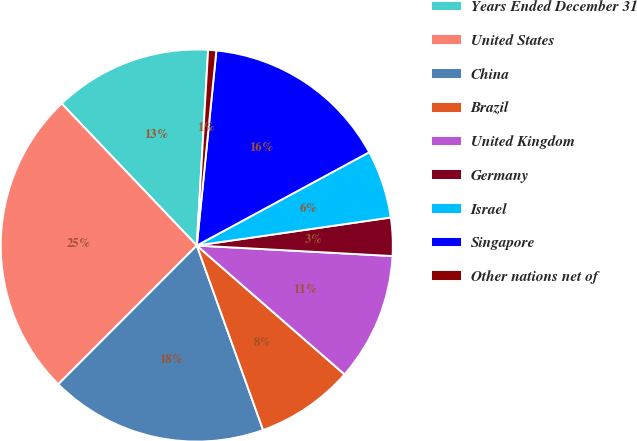Convert chart. <chart><loc_0><loc_0><loc_500><loc_500><pie_chart><fcel>Years Ended December 31<fcel>United States<fcel>China<fcel>Brazil<fcel>United Kingdom<fcel>Germany<fcel>Israel<fcel>Singapore<fcel>Other nations net of<nl><fcel>13.03%<fcel>25.4%<fcel>17.98%<fcel>8.09%<fcel>10.56%<fcel>3.14%<fcel>5.61%<fcel>15.51%<fcel>0.67%<nl></chart> 